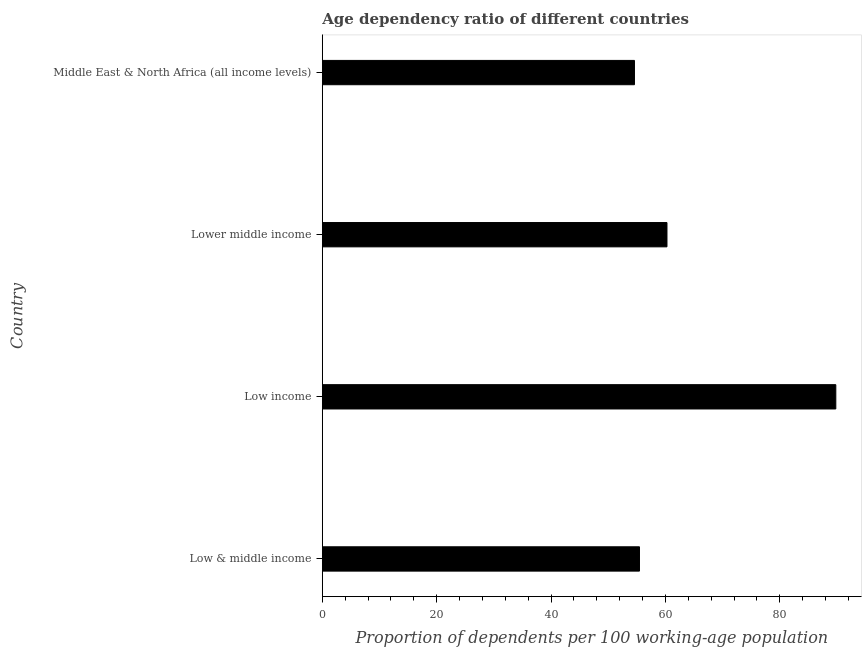Does the graph contain any zero values?
Your answer should be very brief. No. Does the graph contain grids?
Provide a short and direct response. No. What is the title of the graph?
Make the answer very short. Age dependency ratio of different countries. What is the label or title of the X-axis?
Your answer should be very brief. Proportion of dependents per 100 working-age population. What is the label or title of the Y-axis?
Provide a succinct answer. Country. What is the age dependency ratio in Low income?
Provide a succinct answer. 89.78. Across all countries, what is the maximum age dependency ratio?
Offer a very short reply. 89.78. Across all countries, what is the minimum age dependency ratio?
Offer a very short reply. 54.58. In which country was the age dependency ratio minimum?
Give a very brief answer. Middle East & North Africa (all income levels). What is the sum of the age dependency ratio?
Provide a short and direct response. 260.08. What is the difference between the age dependency ratio in Low & middle income and Low income?
Provide a short and direct response. -34.33. What is the average age dependency ratio per country?
Offer a terse response. 65.02. What is the median age dependency ratio?
Keep it short and to the point. 57.86. What is the ratio of the age dependency ratio in Lower middle income to that in Middle East & North Africa (all income levels)?
Provide a succinct answer. 1.1. Is the difference between the age dependency ratio in Low & middle income and Middle East & North Africa (all income levels) greater than the difference between any two countries?
Give a very brief answer. No. What is the difference between the highest and the second highest age dependency ratio?
Your answer should be very brief. 29.52. What is the difference between the highest and the lowest age dependency ratio?
Provide a succinct answer. 35.21. In how many countries, is the age dependency ratio greater than the average age dependency ratio taken over all countries?
Your answer should be compact. 1. How many bars are there?
Offer a terse response. 4. Are the values on the major ticks of X-axis written in scientific E-notation?
Your response must be concise. No. What is the Proportion of dependents per 100 working-age population in Low & middle income?
Your response must be concise. 55.46. What is the Proportion of dependents per 100 working-age population of Low income?
Provide a succinct answer. 89.78. What is the Proportion of dependents per 100 working-age population of Lower middle income?
Provide a short and direct response. 60.26. What is the Proportion of dependents per 100 working-age population in Middle East & North Africa (all income levels)?
Offer a very short reply. 54.58. What is the difference between the Proportion of dependents per 100 working-age population in Low & middle income and Low income?
Make the answer very short. -34.33. What is the difference between the Proportion of dependents per 100 working-age population in Low & middle income and Lower middle income?
Ensure brevity in your answer.  -4.81. What is the difference between the Proportion of dependents per 100 working-age population in Low & middle income and Middle East & North Africa (all income levels)?
Ensure brevity in your answer.  0.88. What is the difference between the Proportion of dependents per 100 working-age population in Low income and Lower middle income?
Keep it short and to the point. 29.52. What is the difference between the Proportion of dependents per 100 working-age population in Low income and Middle East & North Africa (all income levels)?
Give a very brief answer. 35.21. What is the difference between the Proportion of dependents per 100 working-age population in Lower middle income and Middle East & North Africa (all income levels)?
Your answer should be very brief. 5.68. What is the ratio of the Proportion of dependents per 100 working-age population in Low & middle income to that in Low income?
Offer a terse response. 0.62. What is the ratio of the Proportion of dependents per 100 working-age population in Low & middle income to that in Middle East & North Africa (all income levels)?
Offer a very short reply. 1.02. What is the ratio of the Proportion of dependents per 100 working-age population in Low income to that in Lower middle income?
Your answer should be very brief. 1.49. What is the ratio of the Proportion of dependents per 100 working-age population in Low income to that in Middle East & North Africa (all income levels)?
Offer a very short reply. 1.65. What is the ratio of the Proportion of dependents per 100 working-age population in Lower middle income to that in Middle East & North Africa (all income levels)?
Your response must be concise. 1.1. 